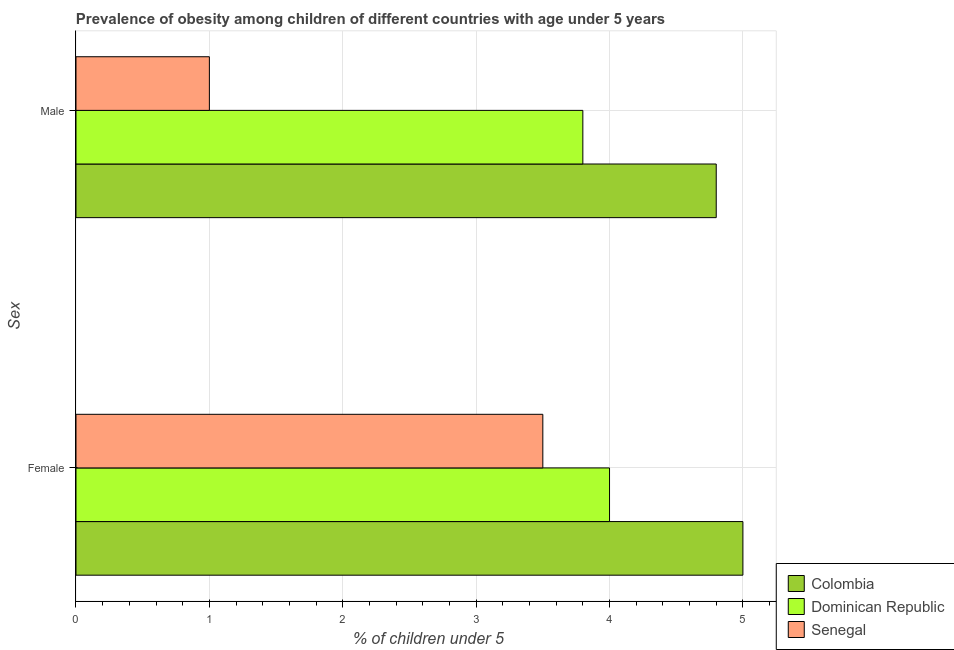How many different coloured bars are there?
Provide a succinct answer. 3. Are the number of bars on each tick of the Y-axis equal?
Make the answer very short. Yes. What is the label of the 2nd group of bars from the top?
Offer a terse response. Female. What is the percentage of obese male children in Senegal?
Your response must be concise. 1. Across all countries, what is the maximum percentage of obese male children?
Ensure brevity in your answer.  4.8. In which country was the percentage of obese female children minimum?
Offer a very short reply. Senegal. What is the difference between the percentage of obese male children in Dominican Republic and that in Colombia?
Your response must be concise. -1. What is the average percentage of obese male children per country?
Your answer should be very brief. 3.2. What is the difference between the percentage of obese male children and percentage of obese female children in Senegal?
Provide a short and direct response. -2.5. What is the ratio of the percentage of obese male children in Senegal to that in Dominican Republic?
Your answer should be very brief. 0.26. Is the percentage of obese female children in Senegal less than that in Dominican Republic?
Your response must be concise. Yes. What does the 2nd bar from the top in Female represents?
Your answer should be very brief. Dominican Republic. What does the 1st bar from the bottom in Female represents?
Ensure brevity in your answer.  Colombia. Are all the bars in the graph horizontal?
Provide a succinct answer. Yes. Are the values on the major ticks of X-axis written in scientific E-notation?
Offer a terse response. No. Does the graph contain grids?
Your response must be concise. Yes. How are the legend labels stacked?
Offer a very short reply. Vertical. What is the title of the graph?
Provide a succinct answer. Prevalence of obesity among children of different countries with age under 5 years. Does "Jordan" appear as one of the legend labels in the graph?
Give a very brief answer. No. What is the label or title of the X-axis?
Ensure brevity in your answer.   % of children under 5. What is the label or title of the Y-axis?
Make the answer very short. Sex. What is the  % of children under 5 in Senegal in Female?
Ensure brevity in your answer.  3.5. What is the  % of children under 5 in Colombia in Male?
Ensure brevity in your answer.  4.8. What is the  % of children under 5 of Dominican Republic in Male?
Keep it short and to the point. 3.8. What is the  % of children under 5 in Senegal in Male?
Give a very brief answer. 1. Across all Sex, what is the maximum  % of children under 5 in Colombia?
Make the answer very short. 5. Across all Sex, what is the maximum  % of children under 5 in Dominican Republic?
Make the answer very short. 4. Across all Sex, what is the maximum  % of children under 5 of Senegal?
Offer a very short reply. 3.5. Across all Sex, what is the minimum  % of children under 5 of Colombia?
Provide a short and direct response. 4.8. Across all Sex, what is the minimum  % of children under 5 in Dominican Republic?
Keep it short and to the point. 3.8. What is the total  % of children under 5 of Colombia in the graph?
Your response must be concise. 9.8. What is the difference between the  % of children under 5 of Colombia in Female and that in Male?
Your answer should be very brief. 0.2. What is the difference between the  % of children under 5 in Dominican Republic in Female and that in Male?
Your answer should be very brief. 0.2. What is the difference between the  % of children under 5 in Senegal in Female and that in Male?
Your answer should be compact. 2.5. What is the average  % of children under 5 in Colombia per Sex?
Your answer should be very brief. 4.9. What is the average  % of children under 5 of Senegal per Sex?
Your answer should be very brief. 2.25. What is the difference between the  % of children under 5 in Colombia and  % of children under 5 in Senegal in Female?
Ensure brevity in your answer.  1.5. What is the difference between the  % of children under 5 in Dominican Republic and  % of children under 5 in Senegal in Female?
Your response must be concise. 0.5. What is the difference between the  % of children under 5 of Colombia and  % of children under 5 of Senegal in Male?
Give a very brief answer. 3.8. What is the ratio of the  % of children under 5 of Colombia in Female to that in Male?
Offer a terse response. 1.04. What is the ratio of the  % of children under 5 of Dominican Republic in Female to that in Male?
Offer a terse response. 1.05. What is the difference between the highest and the second highest  % of children under 5 in Dominican Republic?
Provide a succinct answer. 0.2. What is the difference between the highest and the lowest  % of children under 5 of Colombia?
Ensure brevity in your answer.  0.2. What is the difference between the highest and the lowest  % of children under 5 of Dominican Republic?
Keep it short and to the point. 0.2. What is the difference between the highest and the lowest  % of children under 5 in Senegal?
Ensure brevity in your answer.  2.5. 